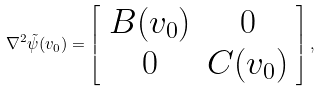Convert formula to latex. <formula><loc_0><loc_0><loc_500><loc_500>\nabla ^ { 2 } \tilde { \psi } ( v _ { 0 } ) = \left [ \begin{array} { c c c } B ( v _ { 0 } ) & 0 \\ 0 & C ( v _ { 0 } ) \end{array} \right ] ,</formula> 